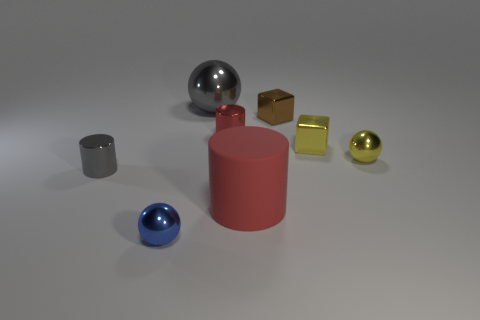Subtract all red cylinders. How many cylinders are left? 1 Subtract all purple balls. How many red cylinders are left? 2 Subtract 1 spheres. How many spheres are left? 2 Add 2 tiny matte cylinders. How many objects exist? 10 Subtract all blue cylinders. Subtract all cyan balls. How many cylinders are left? 3 Subtract all balls. How many objects are left? 5 Subtract all brown metallic cubes. Subtract all small brown metallic cubes. How many objects are left? 6 Add 1 matte cylinders. How many matte cylinders are left? 2 Add 6 small red metal things. How many small red metal things exist? 7 Subtract 1 brown cubes. How many objects are left? 7 